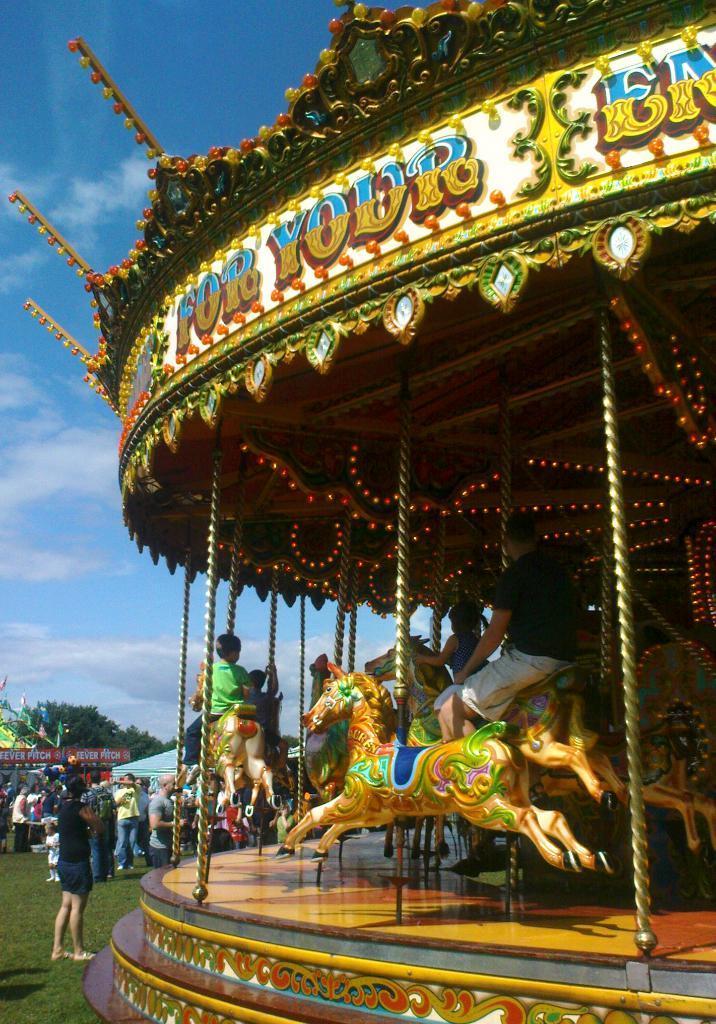How would you summarize this image in a sentence or two? In this image, we can see people, trees and there are fun rides and there are some people sitting on them. At the top, there are clouds in the sky. 